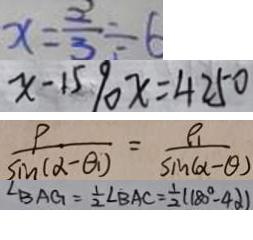Convert formula to latex. <formula><loc_0><loc_0><loc_500><loc_500>x = \frac { 2 } { 3 } \div 6 
 x - 1 5 9 0 x = 4 2 5 0 
 \frac { \rho } { \sin ( \alpha - \theta _ { 1 } ) } = \frac { \rho _ { 1 } } { \sin ( \alpha - \theta ) } 
 \angle B A G = \frac { 1 } { 2 } \angle B A C = \frac { 1 } { 2 } ( 1 8 0 ^ { \circ } - 4 \alpha )</formula> 